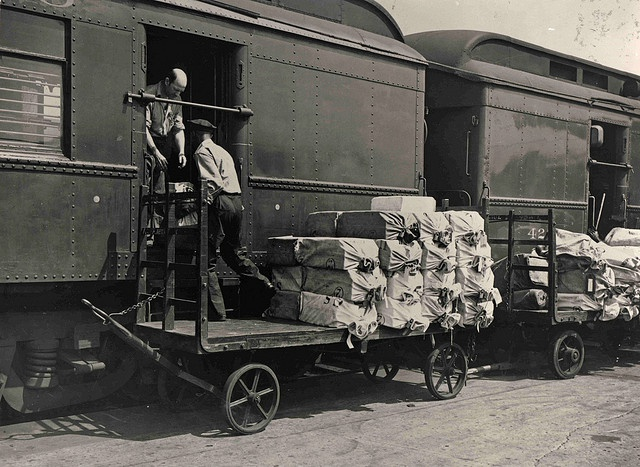Describe the objects in this image and their specific colors. I can see train in lightgray, gray, black, and darkgray tones, people in lightgray, black, gray, and darkgray tones, and people in lightgray, black, gray, and darkgray tones in this image. 